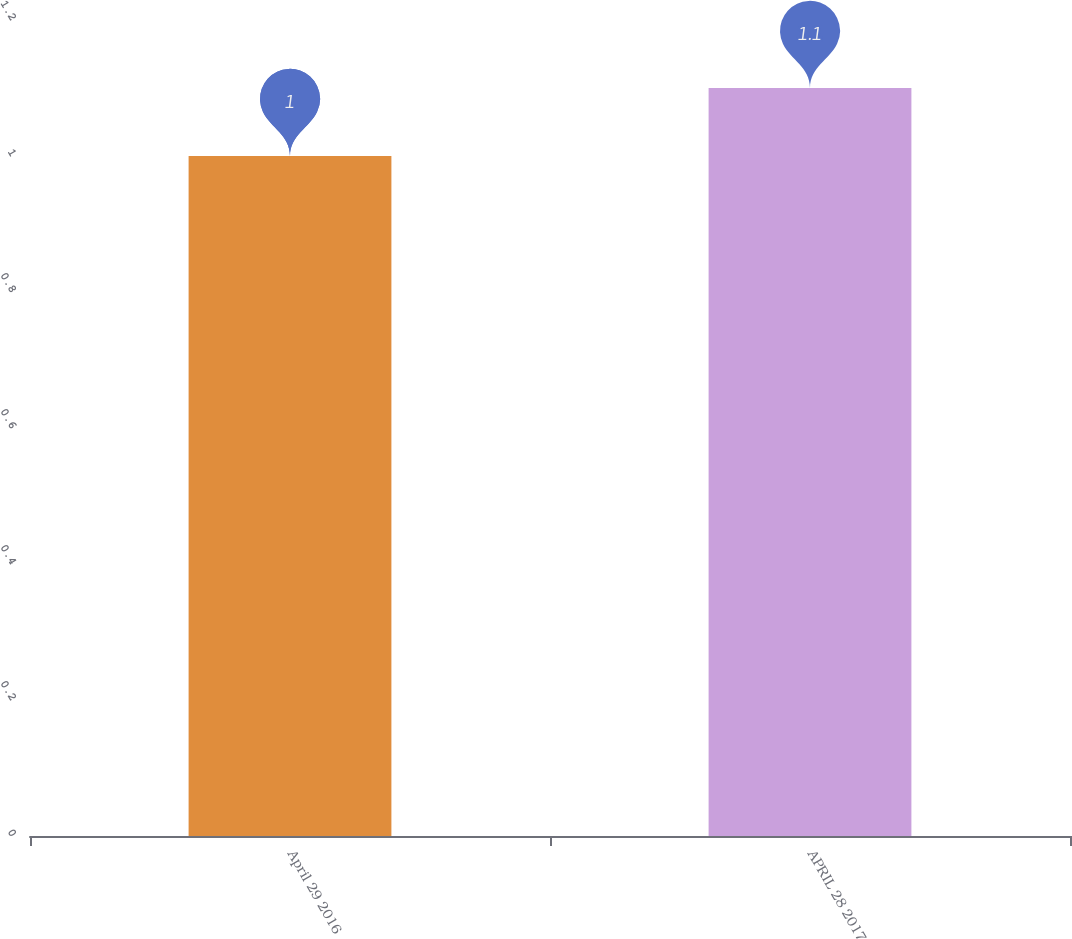Convert chart. <chart><loc_0><loc_0><loc_500><loc_500><bar_chart><fcel>April 29 2016<fcel>APRIL 28 2017<nl><fcel>1<fcel>1.1<nl></chart> 